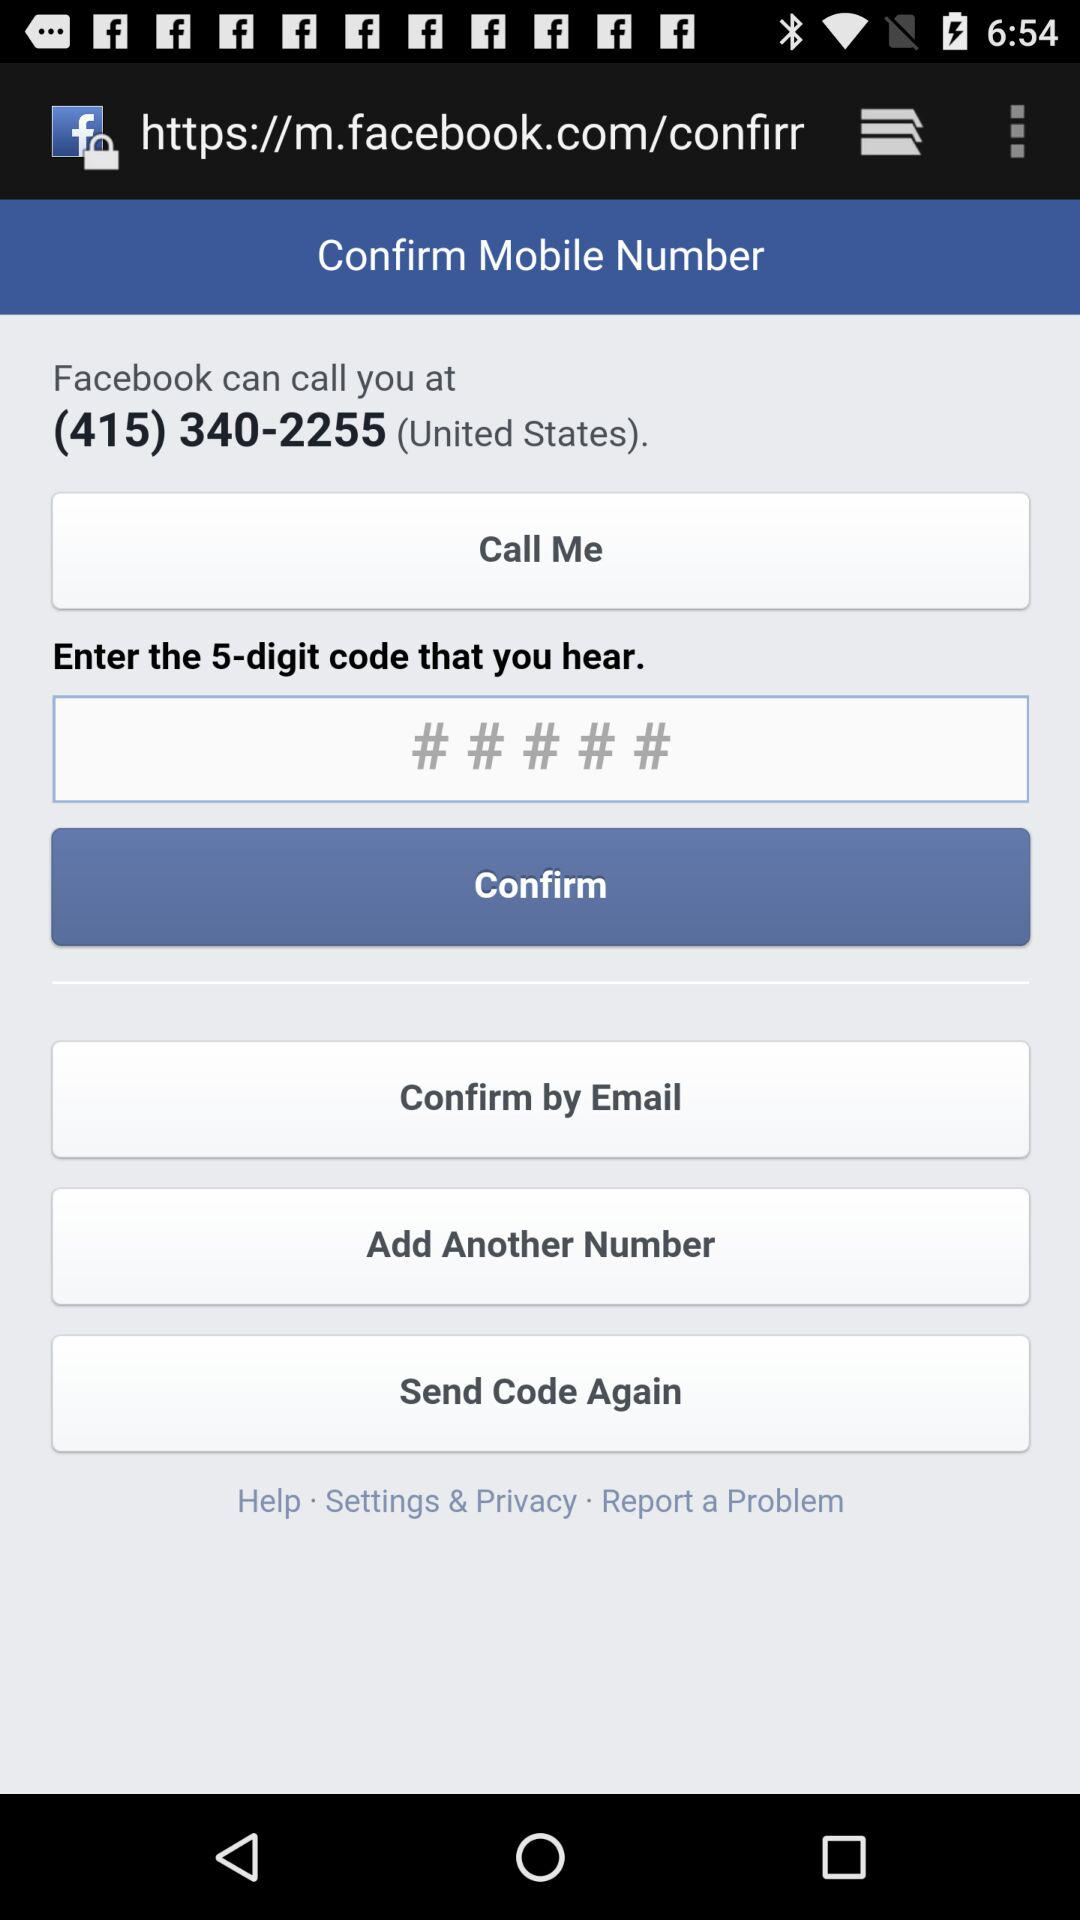How many numbers do I need to enter to confirm my mobile number?
Answer the question using a single word or phrase. 5 